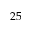Convert formula to latex. <formula><loc_0><loc_0><loc_500><loc_500>2 5</formula> 